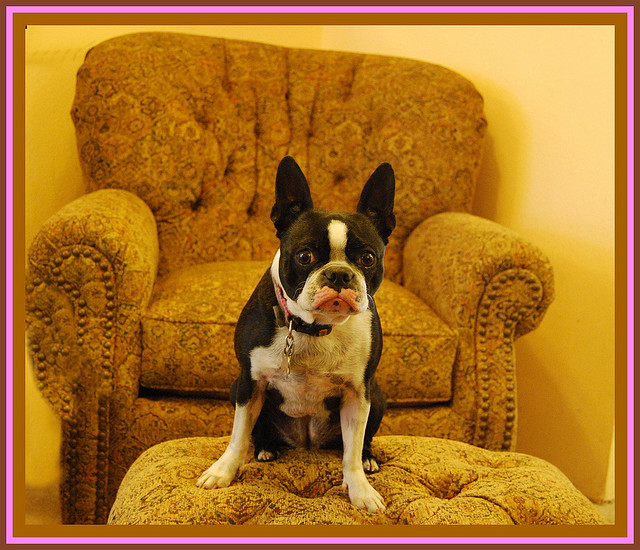<image>How old is this dog? I don't know how old the dog is. How old is this dog? I don't know how old this dog is. It can be between few years and 7 years. 